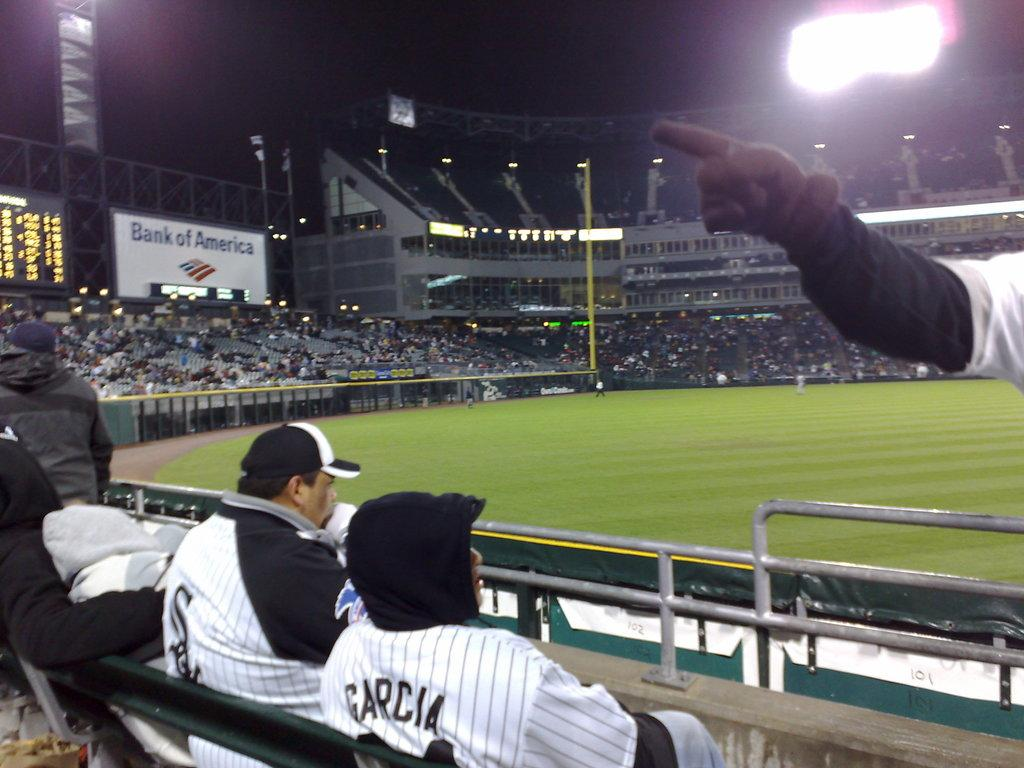Provide a one-sentence caption for the provided image. A couple of men, one wearing a Garcia jersey sitting in the cold at a baseball game. 